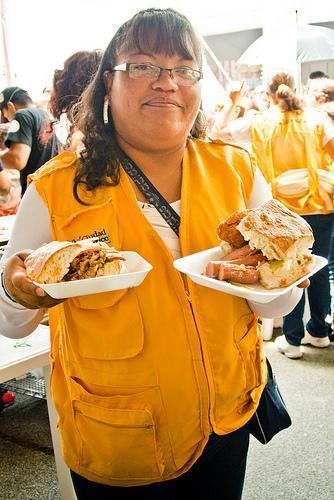How many plates is the woman holding?
Give a very brief answer. 2. 